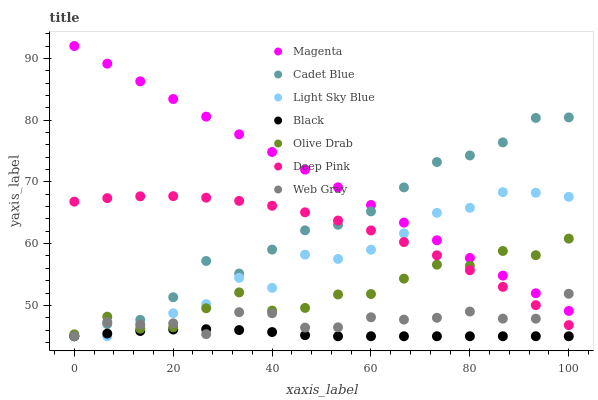Does Black have the minimum area under the curve?
Answer yes or no. Yes. Does Magenta have the maximum area under the curve?
Answer yes or no. Yes. Does Deep Pink have the minimum area under the curve?
Answer yes or no. No. Does Deep Pink have the maximum area under the curve?
Answer yes or no. No. Is Magenta the smoothest?
Answer yes or no. Yes. Is Olive Drab the roughest?
Answer yes or no. Yes. Is Deep Pink the smoothest?
Answer yes or no. No. Is Deep Pink the roughest?
Answer yes or no. No. Does Cadet Blue have the lowest value?
Answer yes or no. Yes. Does Deep Pink have the lowest value?
Answer yes or no. No. Does Magenta have the highest value?
Answer yes or no. Yes. Does Deep Pink have the highest value?
Answer yes or no. No. Is Deep Pink less than Magenta?
Answer yes or no. Yes. Is Deep Pink greater than Black?
Answer yes or no. Yes. Does Cadet Blue intersect Black?
Answer yes or no. Yes. Is Cadet Blue less than Black?
Answer yes or no. No. Is Cadet Blue greater than Black?
Answer yes or no. No. Does Deep Pink intersect Magenta?
Answer yes or no. No. 